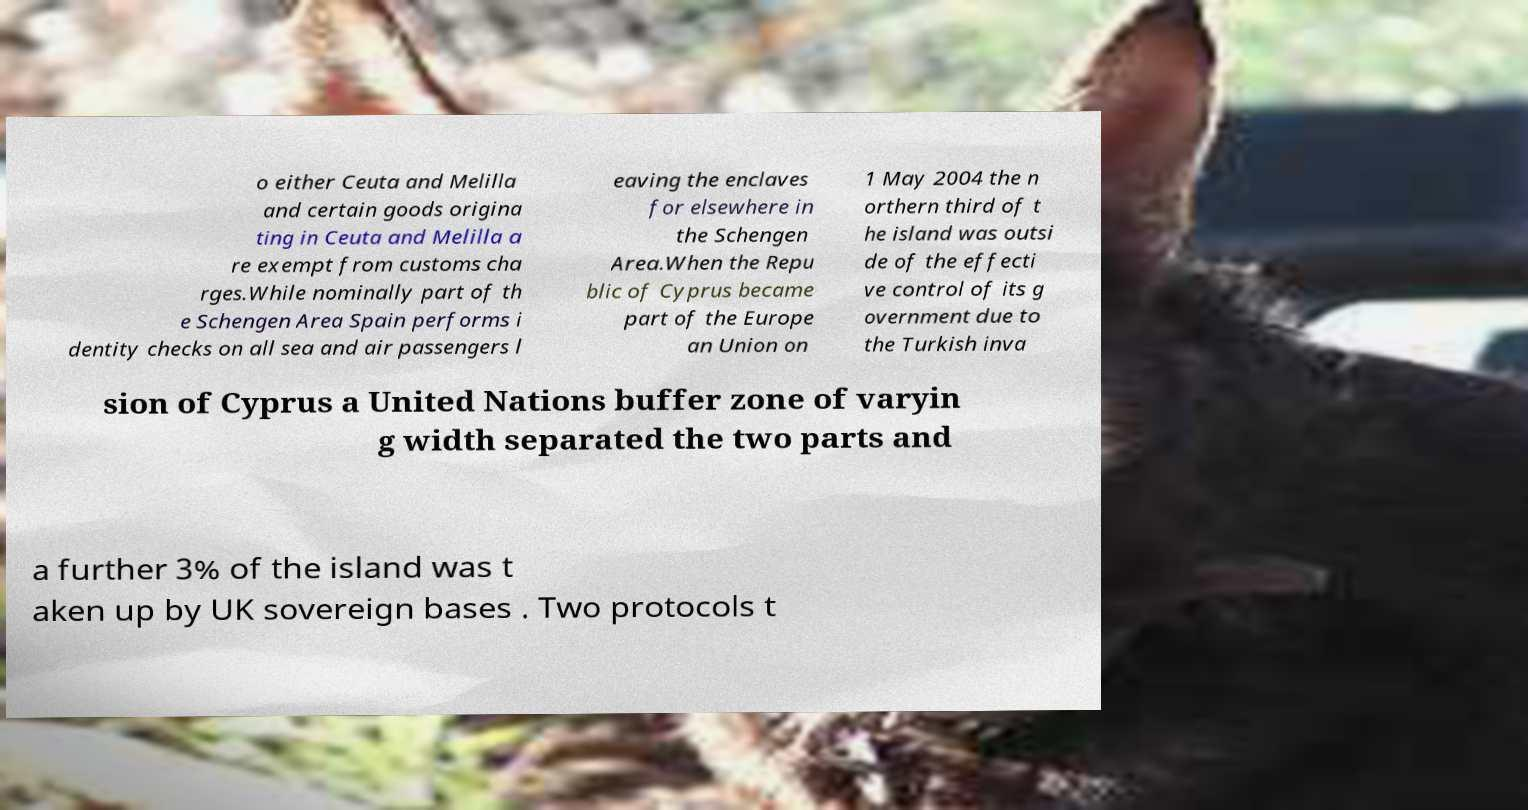Could you assist in decoding the text presented in this image and type it out clearly? o either Ceuta and Melilla and certain goods origina ting in Ceuta and Melilla a re exempt from customs cha rges.While nominally part of th e Schengen Area Spain performs i dentity checks on all sea and air passengers l eaving the enclaves for elsewhere in the Schengen Area.When the Repu blic of Cyprus became part of the Europe an Union on 1 May 2004 the n orthern third of t he island was outsi de of the effecti ve control of its g overnment due to the Turkish inva sion of Cyprus a United Nations buffer zone of varyin g width separated the two parts and a further 3% of the island was t aken up by UK sovereign bases . Two protocols t 